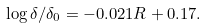<formula> <loc_0><loc_0><loc_500><loc_500>\log { \delta / \delta _ { 0 } } = - 0 . 0 2 1 R + 0 . 1 7 .</formula> 